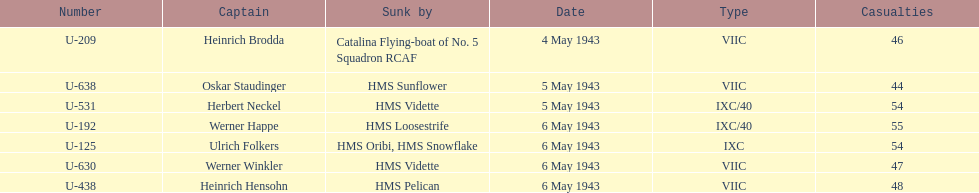Which date had at least 55 casualties? 6 May 1943. 